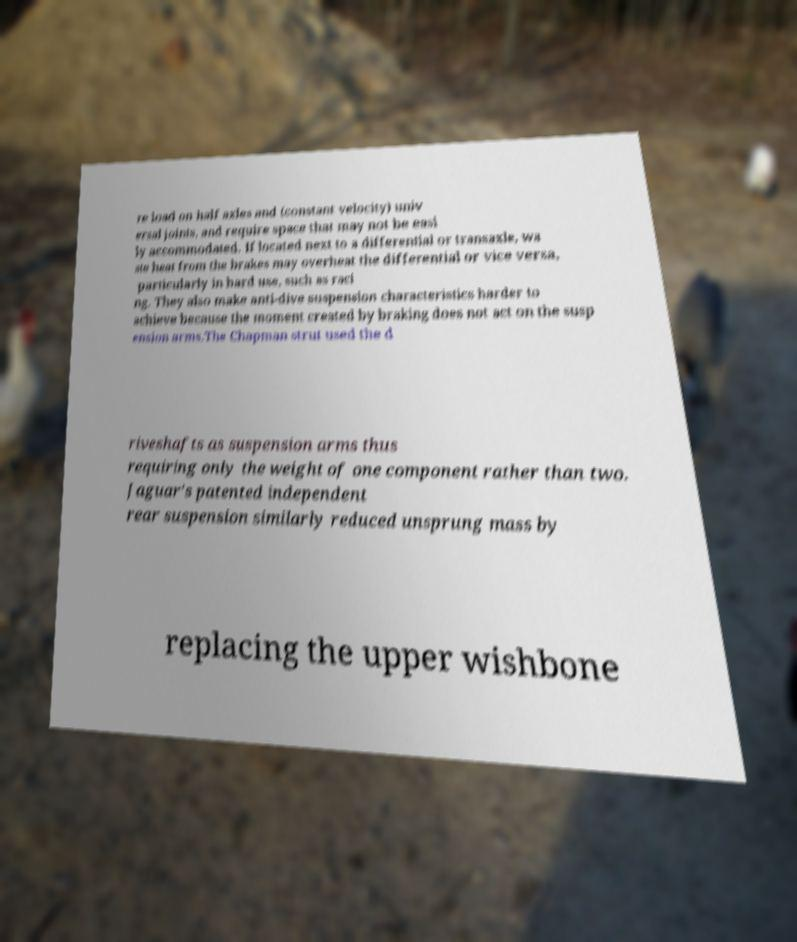I need the written content from this picture converted into text. Can you do that? re load on half axles and (constant velocity) univ ersal joints, and require space that may not be easi ly accommodated. If located next to a differential or transaxle, wa ste heat from the brakes may overheat the differential or vice versa, particularly in hard use, such as raci ng. They also make anti-dive suspension characteristics harder to achieve because the moment created by braking does not act on the susp ension arms.The Chapman strut used the d riveshafts as suspension arms thus requiring only the weight of one component rather than two. Jaguar's patented independent rear suspension similarly reduced unsprung mass by replacing the upper wishbone 